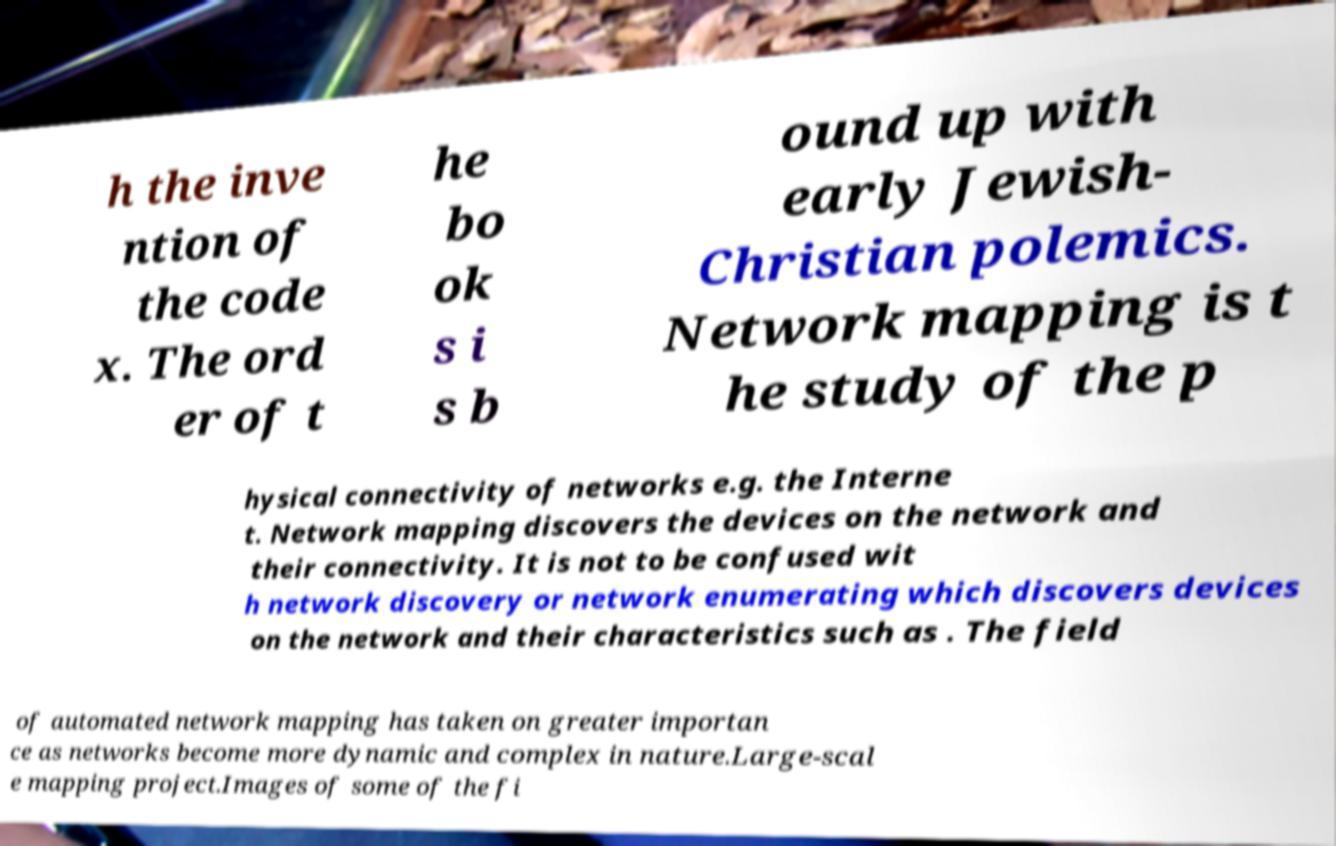Could you assist in decoding the text presented in this image and type it out clearly? h the inve ntion of the code x. The ord er of t he bo ok s i s b ound up with early Jewish- Christian polemics. Network mapping is t he study of the p hysical connectivity of networks e.g. the Interne t. Network mapping discovers the devices on the network and their connectivity. It is not to be confused wit h network discovery or network enumerating which discovers devices on the network and their characteristics such as . The field of automated network mapping has taken on greater importan ce as networks become more dynamic and complex in nature.Large-scal e mapping project.Images of some of the fi 